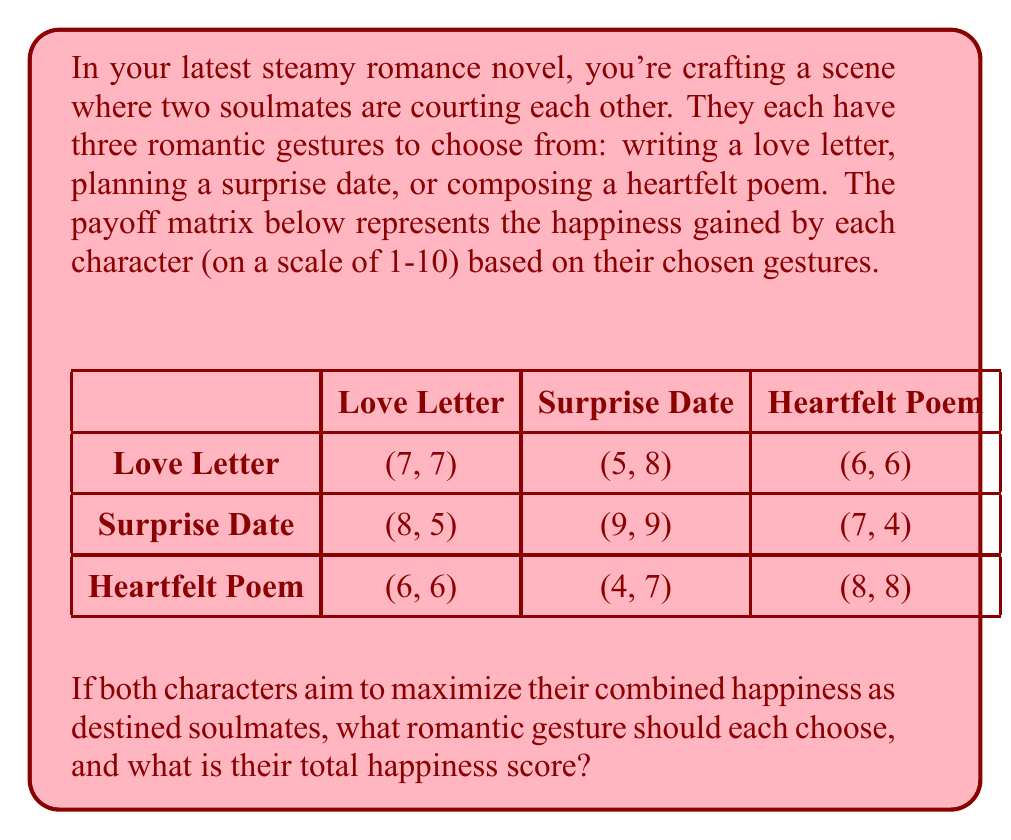What is the answer to this math problem? To solve this problem, we need to:

1. Understand the payoff matrix:
   - Each cell shows (Character 1's happiness, Character 2's happiness)
   - We need to find the choice that maximizes their combined happiness

2. Calculate the total happiness for each combination:
   - Love Letter + Love Letter: 7 + 7 = 14
   - Love Letter + Surprise Date: 5 + 8 = 13
   - Love Letter + Heartfelt Poem: 6 + 6 = 12
   - Surprise Date + Love Letter: 8 + 5 = 13
   - Surprise Date + Surprise Date: 9 + 9 = 18
   - Surprise Date + Heartfelt Poem: 7 + 4 = 11
   - Heartfelt Poem + Love Letter: 6 + 6 = 12
   - Heartfelt Poem + Surprise Date: 4 + 7 = 11
   - Heartfelt Poem + Heartfelt Poem: 8 + 8 = 16

3. Identify the highest combined happiness:
   The highest score is 18, achieved when both characters choose "Surprise Date"

Therefore, to maximize their combined happiness as soulmates, both characters should choose to plan a surprise date for each other.
Answer: Both choose Surprise Date; Total happiness = 18 